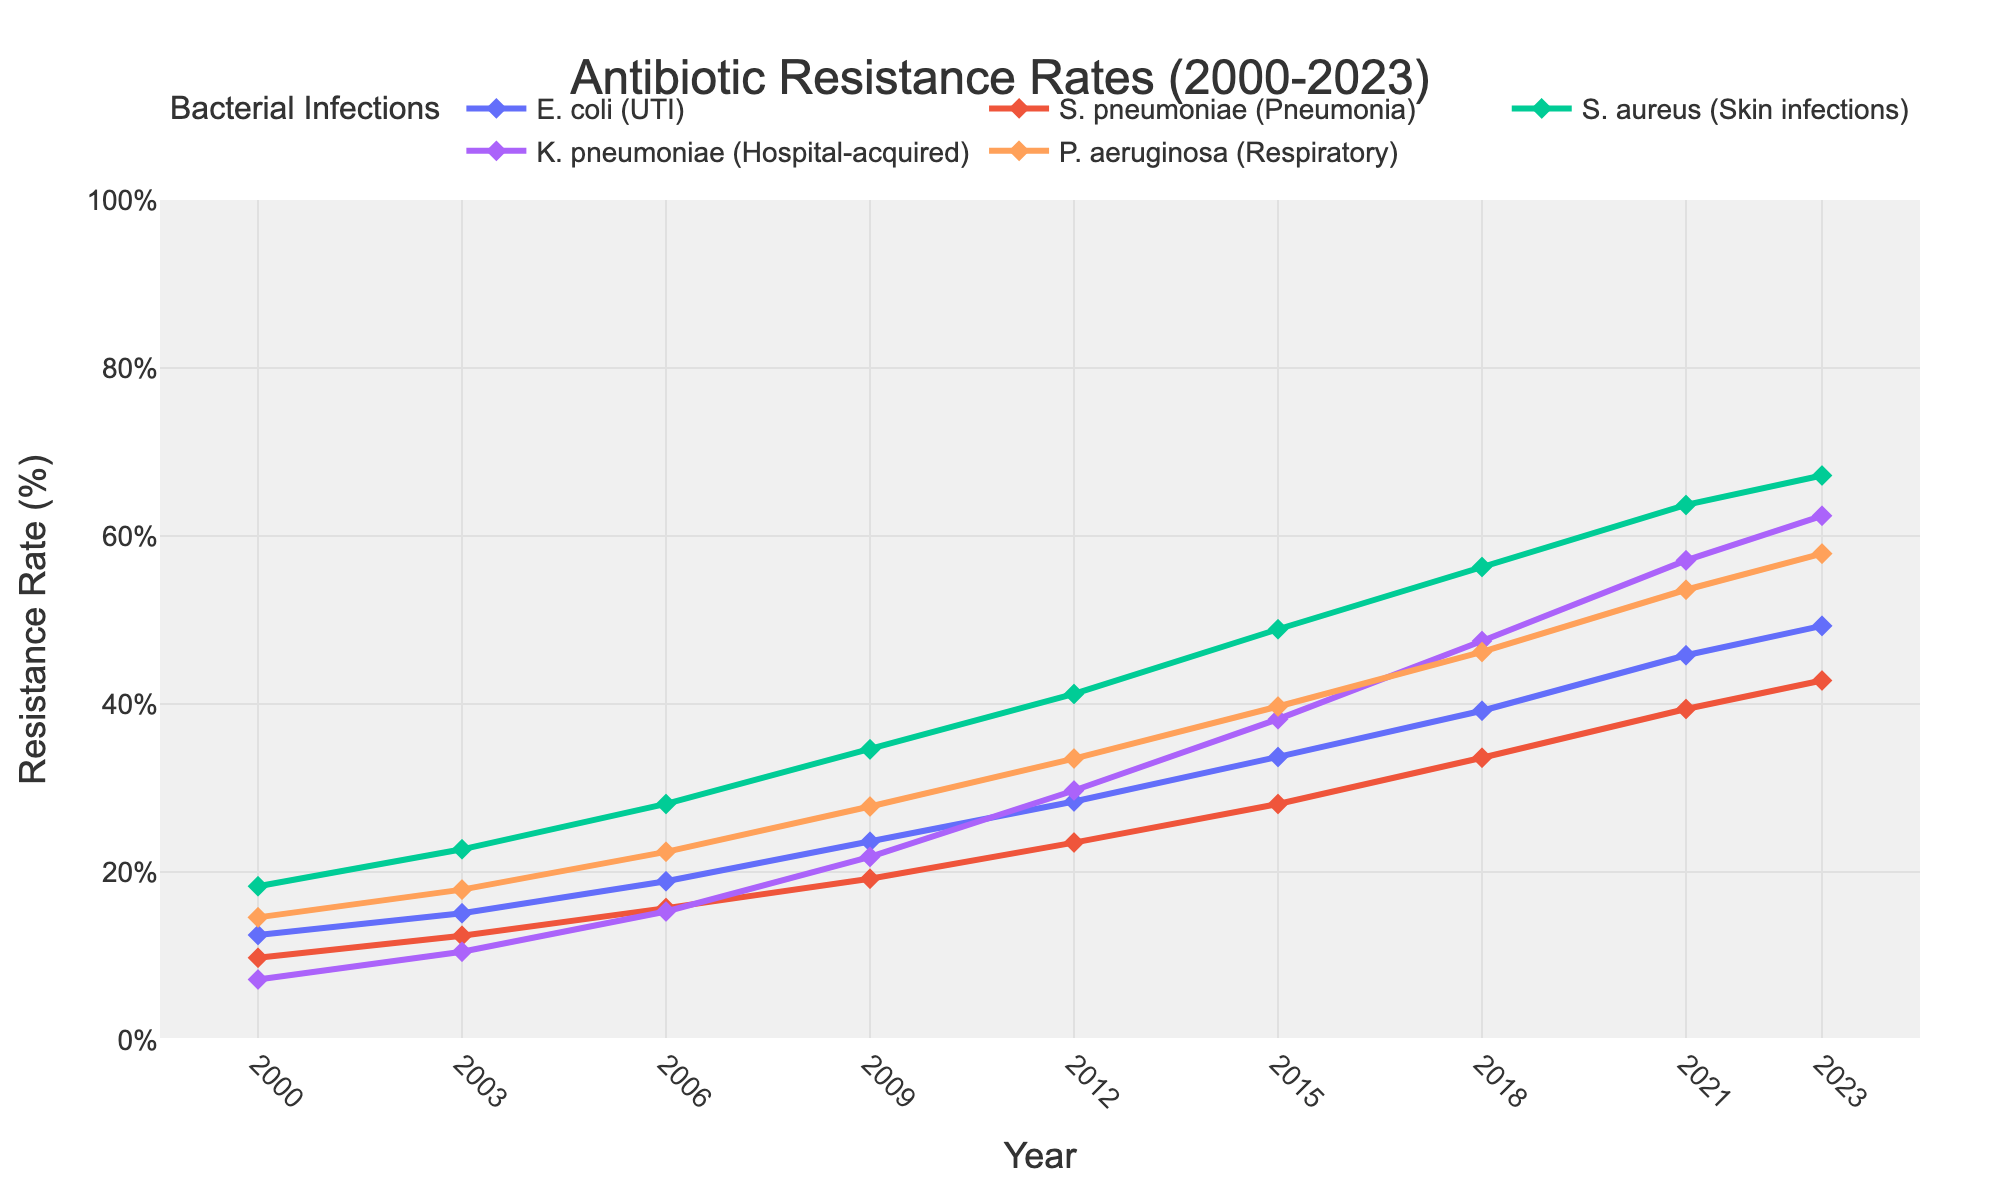Which bacterial infection had the highest antibiotic resistance rate in 2023? By looking at the end of the lines on the right side of the chart for the year 2023, the line representing S. aureus (Skin infections) reaches the highest resistance rate.
Answer: S. aureus (Skin infections) How did the resistance rate of E. coli (UTI) change from 2000 to 2023? The resistance rate of E. coli (UTI) increased. It started at 12.5% in 2000 and rose to 49.3% in 2023.
Answer: Increased Which years show an approximate equal increase in resistance rates for K. pneumoniae (Hospital-acquired)? To find the years, observe the K. pneumoniae line and note the intervals. The increases between 2015 to 2018 and 2018 to 2021 are similar.
Answer: 2015-2018, 2018-2021 What is the difference in resistance rates between P. aeruginosa (Respiratory) and S. pneumoniae (Pneumonia) in 2021? In 2021, P. aeruginosa has a resistance rate of 53.6%, and S. pneumoniae has 39.4%. The difference is calculated as 53.6 - 39.4.
Answer: 14.2% Which bacterial infection showed the most constant increase in resistance rates over the years? By reviewing the plot lines, the S. pneumoniae (Pneumonia) line appears to have steady and gradual increments over the period from 2000 to 2023.
Answer: S. pneumoniae (Pneumonia) On average, how much did the resistance rate of S. aureus (Skin infections) increase per year between 2000 and 2023? S. aureus increased from 18.3% in 2000 to 67.2% in 2023. The difference is 67.2 - 18.3 = 48.9. Dividing this by the 23 years gives the annual average increase.
Answer: 2.13% per year Which two bacterial infections had the closest resistance rates in 2000? By comparing the endpoints of the lines for the year 2000, S. pneumoniae (9.8%) and K. pneumoniae (7.2%) were the closest. The difference between them is the smallest.
Answer: S. pneumoniae and K. pneumoniae 